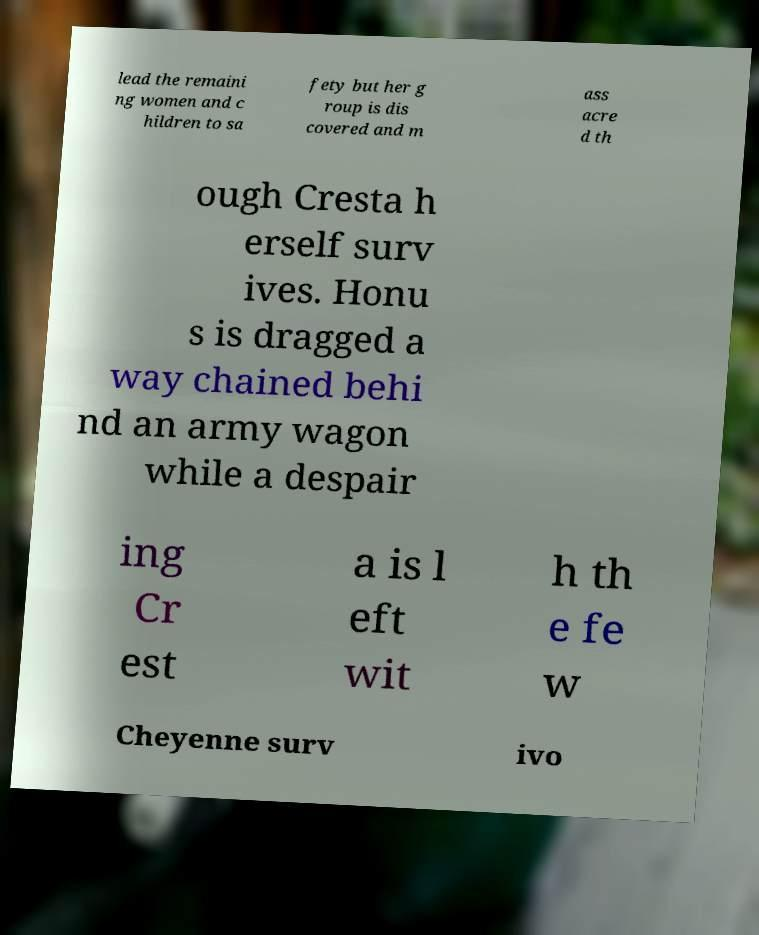Can you read and provide the text displayed in the image?This photo seems to have some interesting text. Can you extract and type it out for me? lead the remaini ng women and c hildren to sa fety but her g roup is dis covered and m ass acre d th ough Cresta h erself surv ives. Honu s is dragged a way chained behi nd an army wagon while a despair ing Cr est a is l eft wit h th e fe w Cheyenne surv ivo 